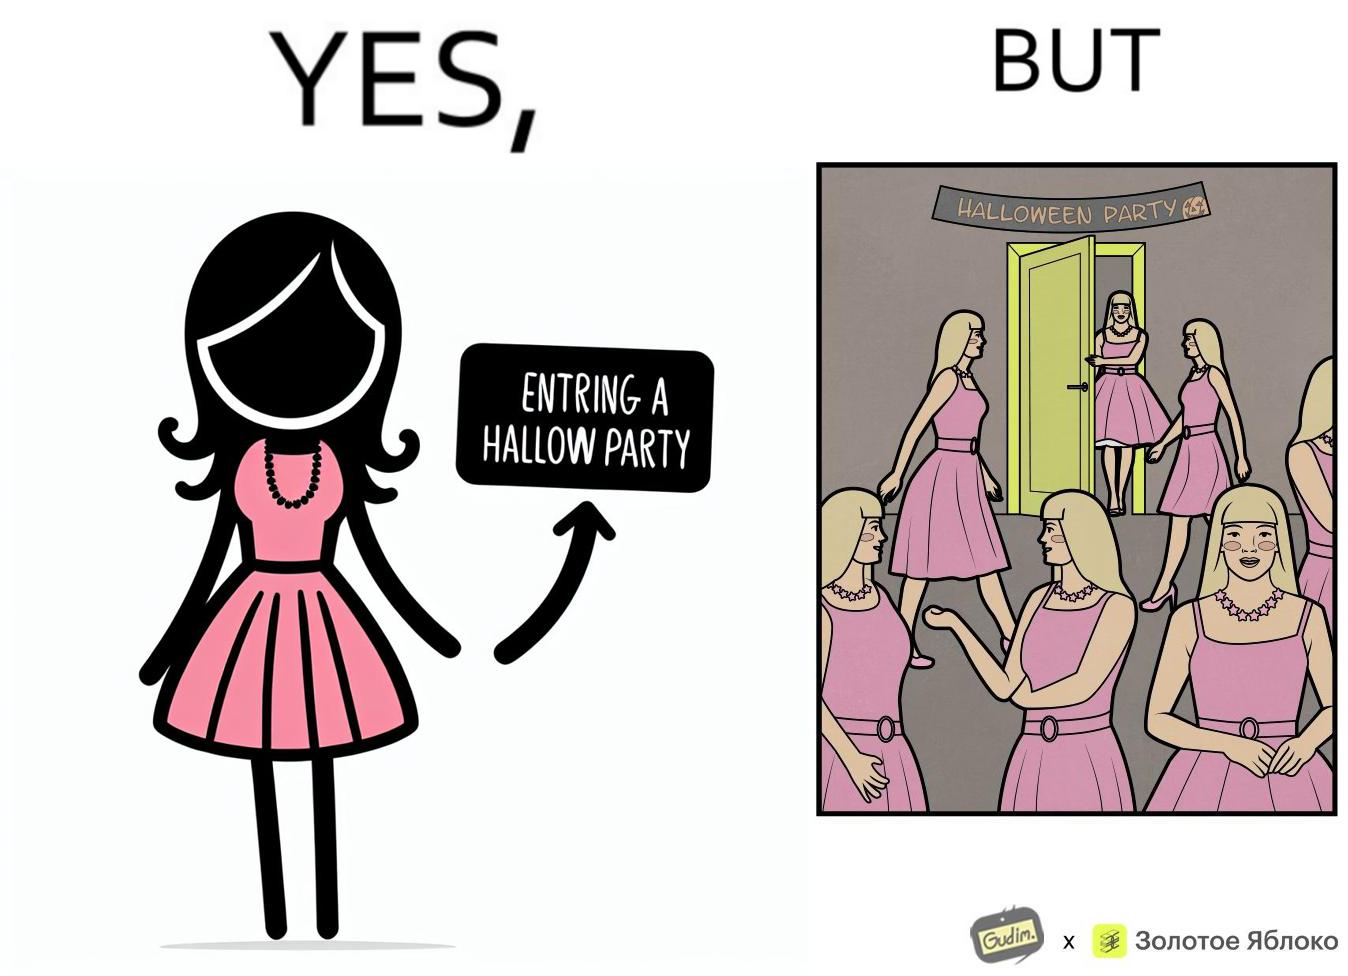Is this image satirical or non-satirical? Yes, this image is satirical. 